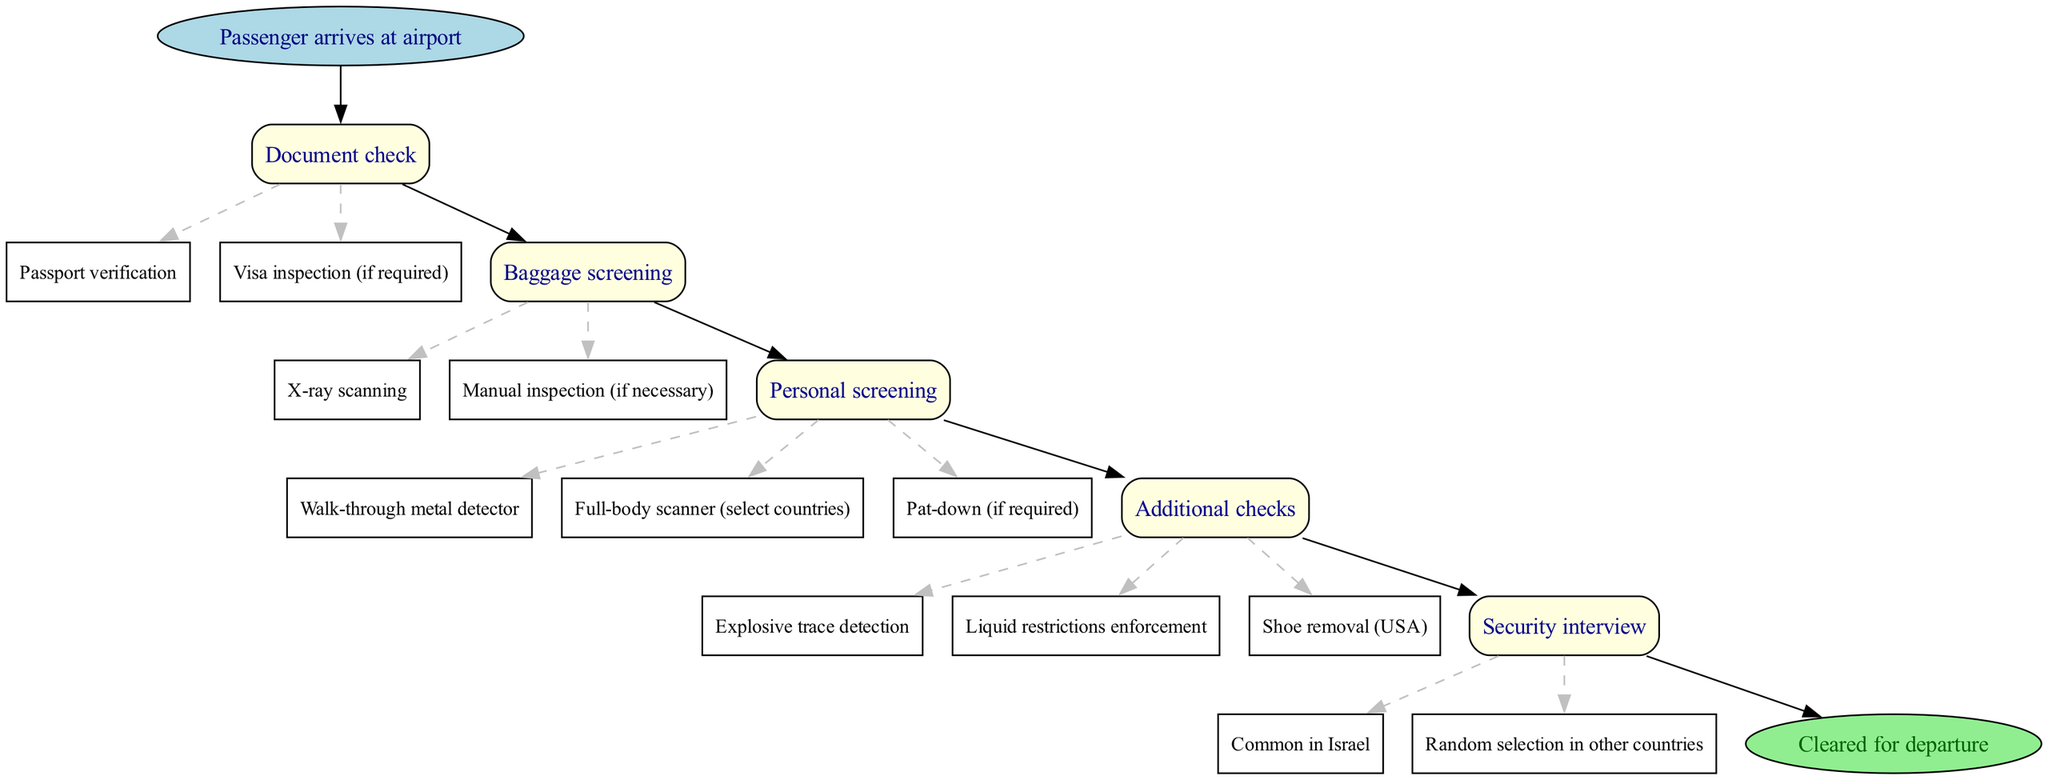What is the first step after the passenger arrives at the airport? The first step indicated in the flow chart after the passenger arrives at the airport is the "Document check".
Answer: Document check How many main screening procedures are shown in the diagram? By counting the number of different nodes that indicate main procedures, we identify five main screening procedural nodes: Document check, Baggage screening, Personal screening, Additional checks, and Security interview.
Answer: Five What needs to be checked during the Document check? The edges branching from the "Document check" node specify that "Passport verification" and "Visa inspection (if required)" are the checks that need to occur.
Answer: Passport verification, Visa inspection (if required) Which country is noted for having a security interview as common practice? The flow chart specifically mentions that a security interview is "Common in Israel", highlighting its unique practice in that country compared to others.
Answer: Israel What is unique about the Additional checks node in the USA? The diagram highlights specifically that "Shoe removal" is an additional requirement enforced in the USA during the Additional checks step.
Answer: Shoe removal (USA) What follows after the Personal screening step? According to the flow chart, the Personal screening step leads directly to the Additional checks step, making it clear what comes next in the sequence.
Answer: Additional checks Which screening step includes options for a full-body scanner? The Personal screening step includes "Full-body scanner (select countries)" as one of the methods of screening, indicating variable procedures across countries.
Answer: Full-body scanner (select countries) How are edges represented in the diagram? In the diagram, edges are represented as lines connecting nodes, indicating the flow of the process and are described in dashed lines for sub-nodes under main nodes.
Answer: Dashed lines What denotes the final step in the flow chart? The final step in the flow chart is denoted by the "Cleared for departure" node, which signifies the end of the screening process successfully.
Answer: Cleared for departure 